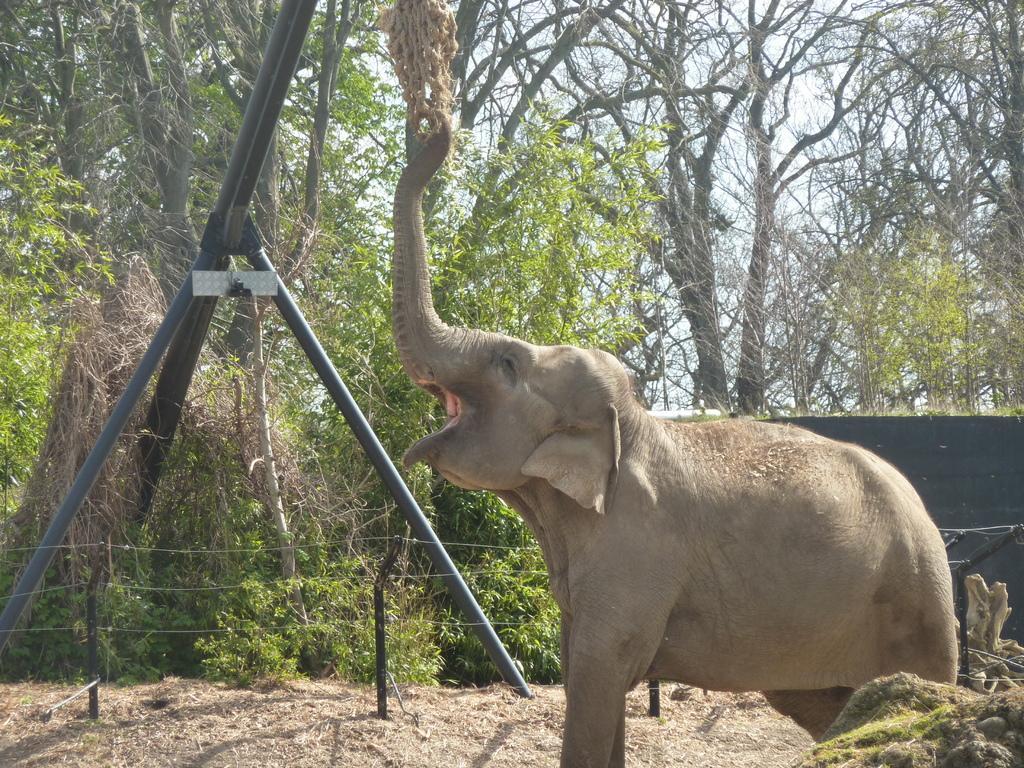Please provide a concise description of this image. In this picture we can see an elephant, grass, iron rods, fence, trees and objects. In the background of the image we can see the sky. 